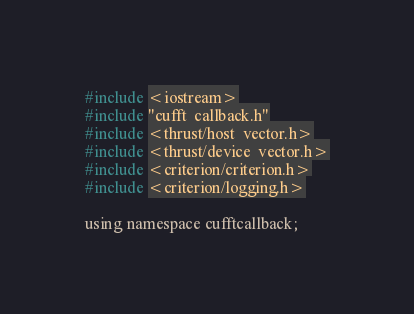Convert code to text. <code><loc_0><loc_0><loc_500><loc_500><_Cuda_>#include <iostream>
#include "cufft_callback.h"
#include <thrust/host_vector.h>
#include <thrust/device_vector.h>
#include <criterion/criterion.h>
#include <criterion/logging.h>

using namespace cufftcallback;
</code> 